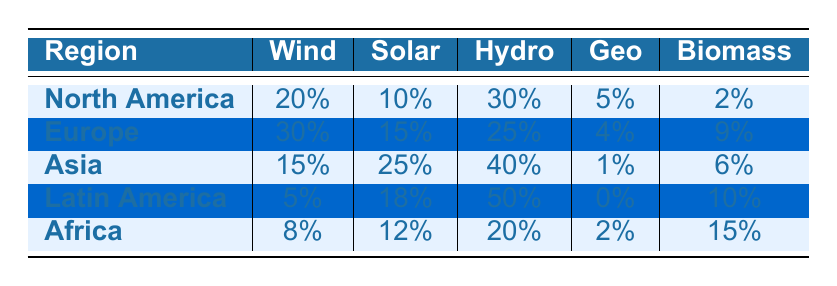What is the percentage of Wind Energy Adoption in Europe? Referring to the table, the Wind Energy Percentage for Europe is 30%.
Answer: 30% Which region has the highest percentage of Hydropower Adoption? By checking the table, Latin America has the highest Hydropower Percentage at 50%.
Answer: Latin America What is the average percentage of Solar Energy Adoption across all regions? To calculate the average, sum the Solar Energy Percentages: (10 + 15 + 25 + 18 + 12) = 80%. Then divide by the number of regions (5): 80/5 = 16%.
Answer: 16% Is the Biomass Percentage in Africa greater than that in Asia? According to the table, Africa has a Biomass Percentage of 15%, while Asia has 6%. Since 15 is greater than 6, the statement is true.
Answer: Yes Which region has a lower percentage of Geothermal Energy Adoption, Asia or North America? The table shows Geothermal Percentages of 1% for Asia and 5% for North America. Since 1% is lower than 5%, Asia has the lower percentage.
Answer: Asia What is the difference in Wind Energy Adoption between North America and Europe? From the table, North America's Wind Energy Percentage is 20% and Europe's is 30%. The difference is calculated as 30% - 20% = 10%.
Answer: 10% Is the total of Wind Energy Adoption across all regions greater than 100%? Adding the Wind Energy Percentages from all regions: (20 + 30 + 15 + 5 + 8) = 78%. Since 78% is less than 100%, the answer is no.
Answer: No Which region has the lowest percentage of Wind Energy among all regions? Looking at the Wind Energy Percentages, North America (20%), Europe (30%), Asia (15%), Latin America (5%), and Africa (8%), Latin America has the lowest at 5%.
Answer: Latin America What region has the highest total of Renewable Energy Adoption considering all types? To find the total for each region: North America (20 + 10 + 30 + 5 + 2 = 67), Europe (30 + 15 + 25 + 4 + 9 = 83), Asia (15 + 25 + 40 + 1 + 6 = 87), Latin America (5 + 18 + 50 + 0 + 10 = 83), Africa (8 + 12 + 20 + 2 + 15 = 57). Asia has the highest total at 87.
Answer: Asia 